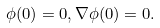<formula> <loc_0><loc_0><loc_500><loc_500>\phi ( 0 ) = 0 , \nabla \phi ( 0 ) = 0 .</formula> 